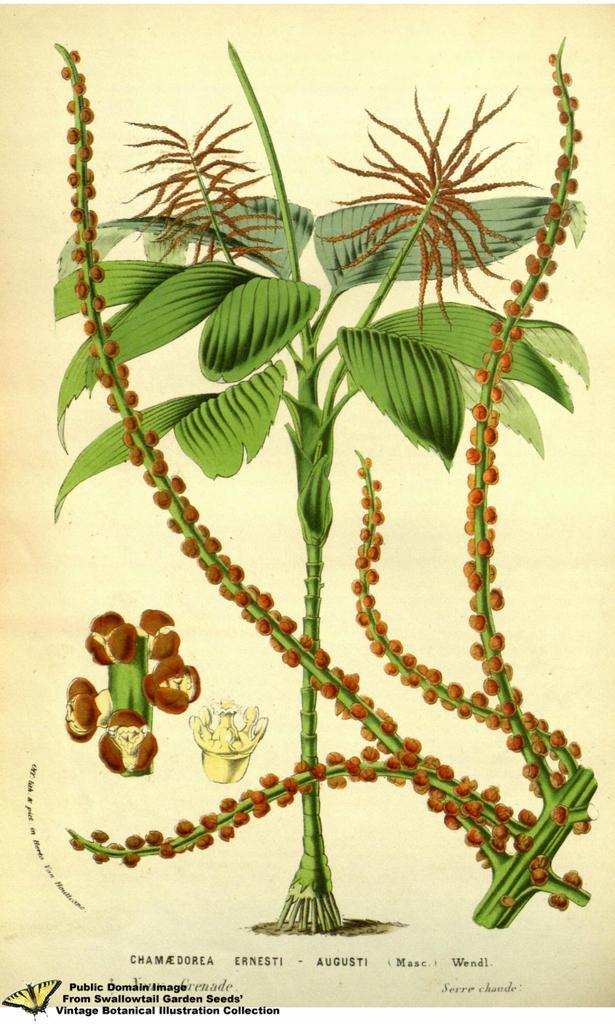Please provide a concise description of this image. In this picture I can observe a drawing of a plant on the paper. I can observe cream and brown colors on the paper. There is some text on the bottom of the picture. The background is in cream color. 